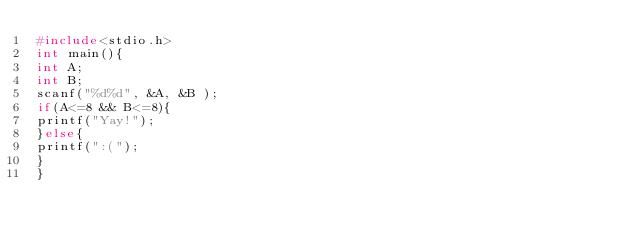Convert code to text. <code><loc_0><loc_0><loc_500><loc_500><_C_>#include<stdio.h>
int main(){
int A;
int B;
scanf("%d%d", &A, &B );
if(A<=8 && B<=8){
printf("Yay!");
}else{
printf(":(");
}
}</code> 